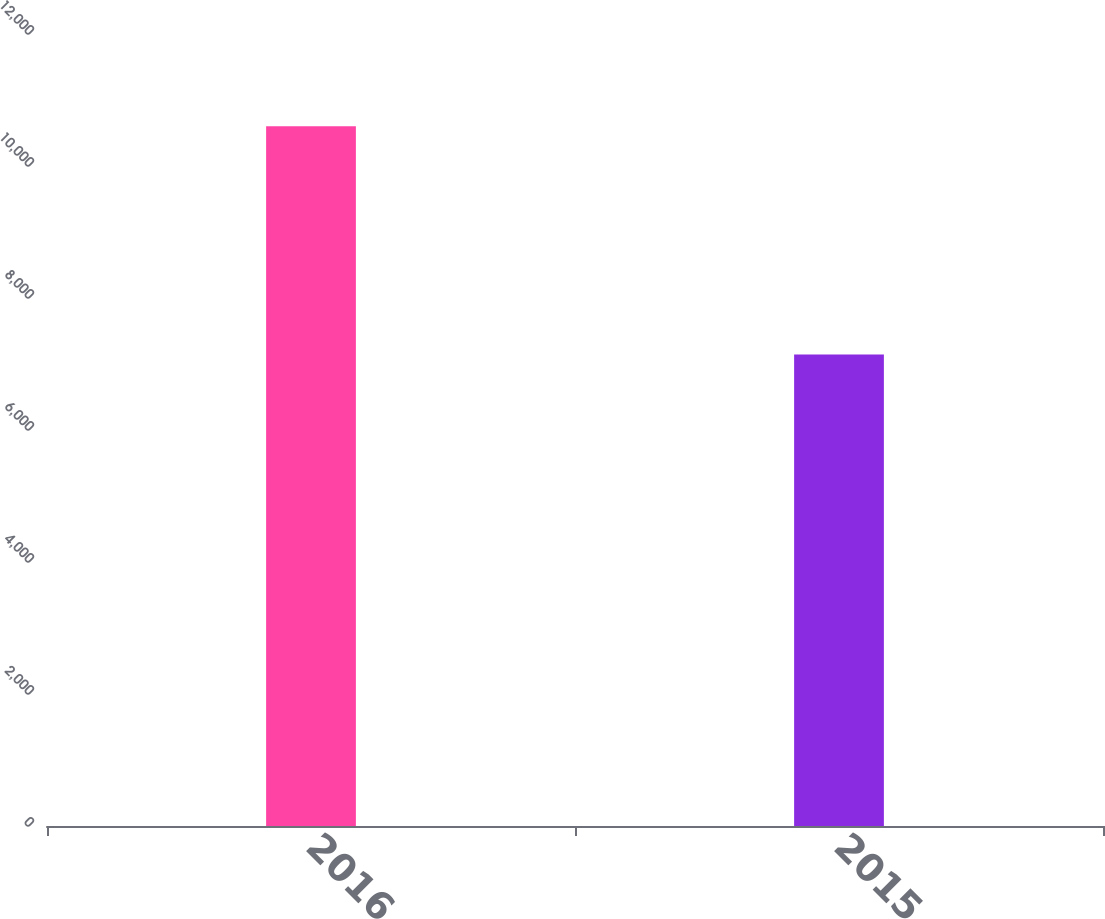Convert chart to OTSL. <chart><loc_0><loc_0><loc_500><loc_500><bar_chart><fcel>2016<fcel>2015<nl><fcel>10604<fcel>7144<nl></chart> 